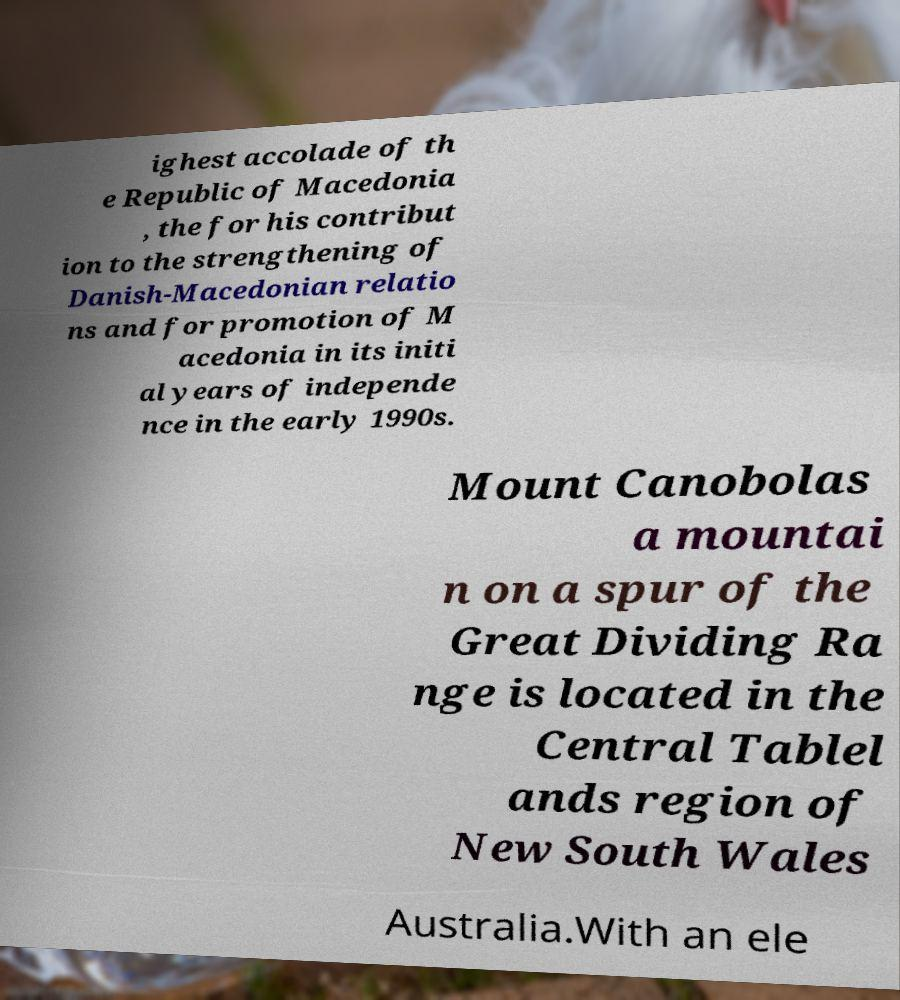Please read and relay the text visible in this image. What does it say? ighest accolade of th e Republic of Macedonia , the for his contribut ion to the strengthening of Danish-Macedonian relatio ns and for promotion of M acedonia in its initi al years of independe nce in the early 1990s. Mount Canobolas a mountai n on a spur of the Great Dividing Ra nge is located in the Central Tablel ands region of New South Wales Australia.With an ele 